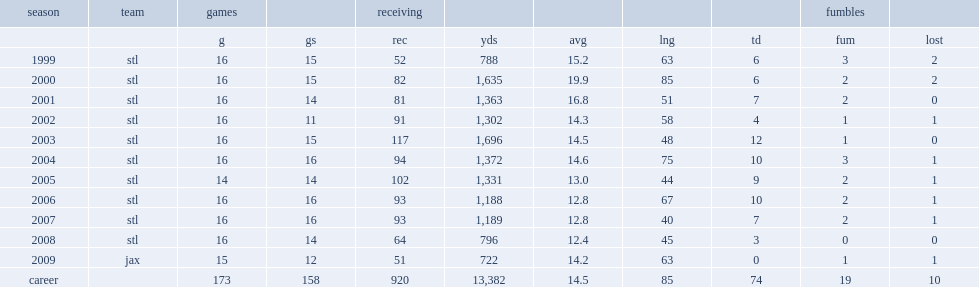How many touchdowns did holt get in his career? 74.0. 